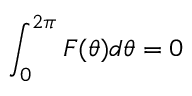Convert formula to latex. <formula><loc_0><loc_0><loc_500><loc_500>\int _ { 0 } ^ { 2 \pi } F ( \theta ) d \theta = 0</formula> 